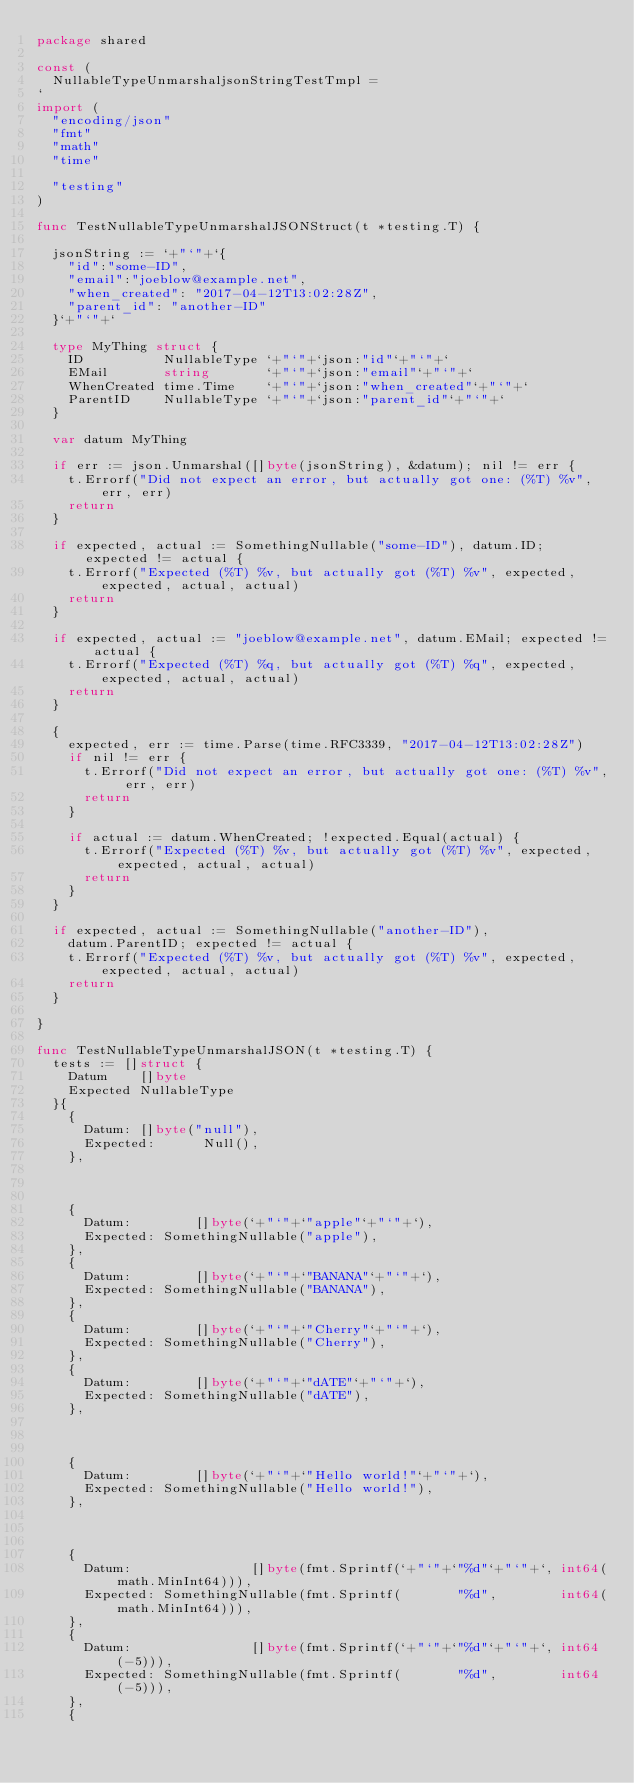Convert code to text. <code><loc_0><loc_0><loc_500><loc_500><_Go_>package shared

const (
	NullableTypeUnmarshaljsonStringTestTmpl =
`
import (
	"encoding/json"
	"fmt"
	"math"
	"time"

	"testing"
)

func TestNullableTypeUnmarshalJSONStruct(t *testing.T) {

	jsonString := `+"`"+`{
		"id":"some-ID",
		"email":"joeblow@example.net",
		"when_created": "2017-04-12T13:02:28Z",
		"parent_id": "another-ID"
	}`+"`"+`

	type MyThing struct {
		ID          NullableType `+"`"+`json:"id"`+"`"+`
		EMail       string       `+"`"+`json:"email"`+"`"+`
		WhenCreated time.Time    `+"`"+`json:"when_created"`+"`"+`
		ParentID    NullableType `+"`"+`json:"parent_id"`+"`"+`
	}

	var datum MyThing

	if err := json.Unmarshal([]byte(jsonString), &datum); nil != err {
		t.Errorf("Did not expect an error, but actually got one: (%T) %v", err, err)
		return
	}

	if expected, actual := SomethingNullable("some-ID"), datum.ID; expected != actual {
		t.Errorf("Expected (%T) %v, but actually got (%T) %v", expected, expected, actual, actual)
		return
	}

	if expected, actual := "joeblow@example.net", datum.EMail; expected != actual {
		t.Errorf("Expected (%T) %q, but actually got (%T) %q", expected, expected, actual, actual)
		return
	}

	{
		expected, err := time.Parse(time.RFC3339, "2017-04-12T13:02:28Z")
		if nil != err {
			t.Errorf("Did not expect an error, but actually got one: (%T) %v", err, err)
			return
		}

		if actual := datum.WhenCreated; !expected.Equal(actual) {
			t.Errorf("Expected (%T) %v, but actually got (%T) %v", expected, expected, actual, actual)
			return
		}
	}

	if expected, actual := SomethingNullable("another-ID"),
		datum.ParentID; expected != actual {
		t.Errorf("Expected (%T) %v, but actually got (%T) %v", expected, expected, actual, actual)
		return
	}

}

func TestNullableTypeUnmarshalJSON(t *testing.T) {
	tests := []struct {
		Datum    []byte
		Expected NullableType
	}{
		{
			Datum: []byte("null"),
			Expected:      Null(),
		},



		{
			Datum:        []byte(`+"`"+`"apple"`+"`"+`),
			Expected: SomethingNullable("apple"),
		},
		{
			Datum:        []byte(`+"`"+`"BANANA"`+"`"+`),
			Expected: SomethingNullable("BANANA"),
		},
		{
			Datum:        []byte(`+"`"+`"Cherry"`+"`"+`),
			Expected: SomethingNullable("Cherry"),
		},
		{
			Datum:        []byte(`+"`"+`"dATE"`+"`"+`),
			Expected: SomethingNullable("dATE"),
		},



		{
			Datum:        []byte(`+"`"+`"Hello world!"`+"`"+`),
			Expected: SomethingNullable("Hello world!"),
		},



		{
			Datum:               []byte(fmt.Sprintf(`+"`"+`"%d"`+"`"+`, int64(math.MinInt64))),
			Expected: SomethingNullable(fmt.Sprintf(       "%d",        int64(math.MinInt64))),
		},
		{
			Datum:               []byte(fmt.Sprintf(`+"`"+`"%d"`+"`"+`, int64(-5))),
			Expected: SomethingNullable(fmt.Sprintf(       "%d",        int64(-5))),
		},
		{</code> 